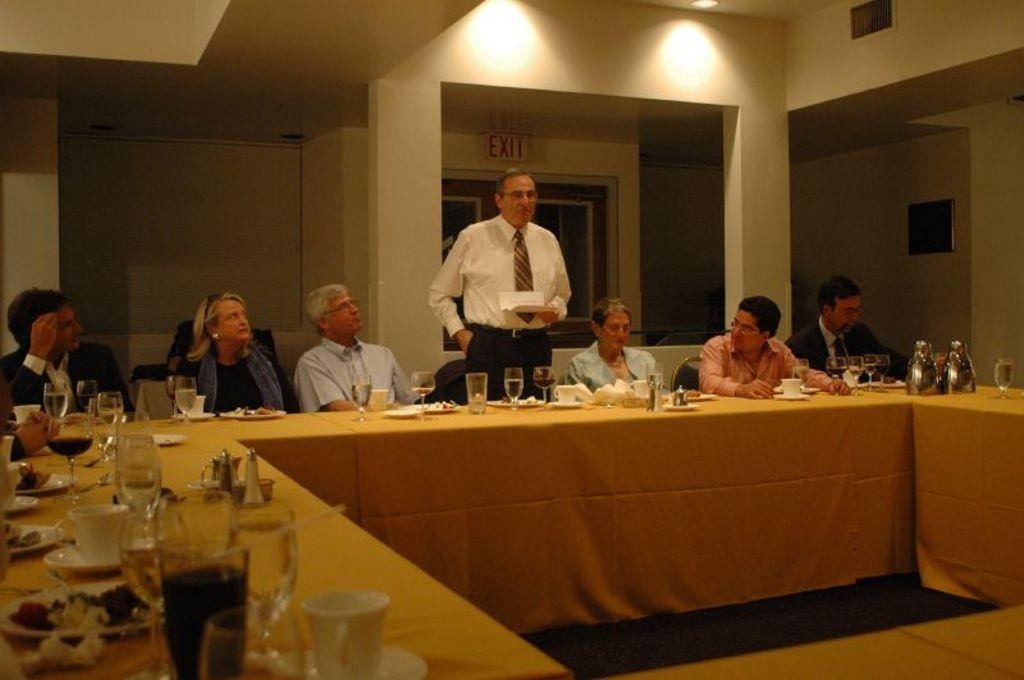What is the man in the image doing? The man is standing in the image. What are the people in the image doing? The people are sitting in the image. What object can be seen in the image that is typically used for eating or drinking? There is a table in the image, and on it, there is a wine glass, a tea cup, and food on a plate. What type of beverages might be associated with the wine glass and tea cup? The wine glass might be associated with wine, while the tea cup might be associated with tea or another hot beverage. What day of the week is it in the image? The day of the week is not mentioned or depicted in the image, so it cannot be determined. What does the man in the image feel ashamed about? There is no indication in the image that the man is feeling ashamed about anything. 